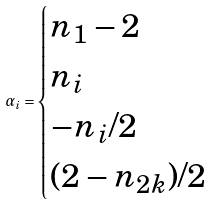<formula> <loc_0><loc_0><loc_500><loc_500>\alpha _ { i } = \begin{cases} n _ { 1 } - 2 & \\ n _ { i } & \\ - n _ { i } / 2 & \\ ( 2 - n _ { 2 k } ) / 2 & \end{cases}</formula> 